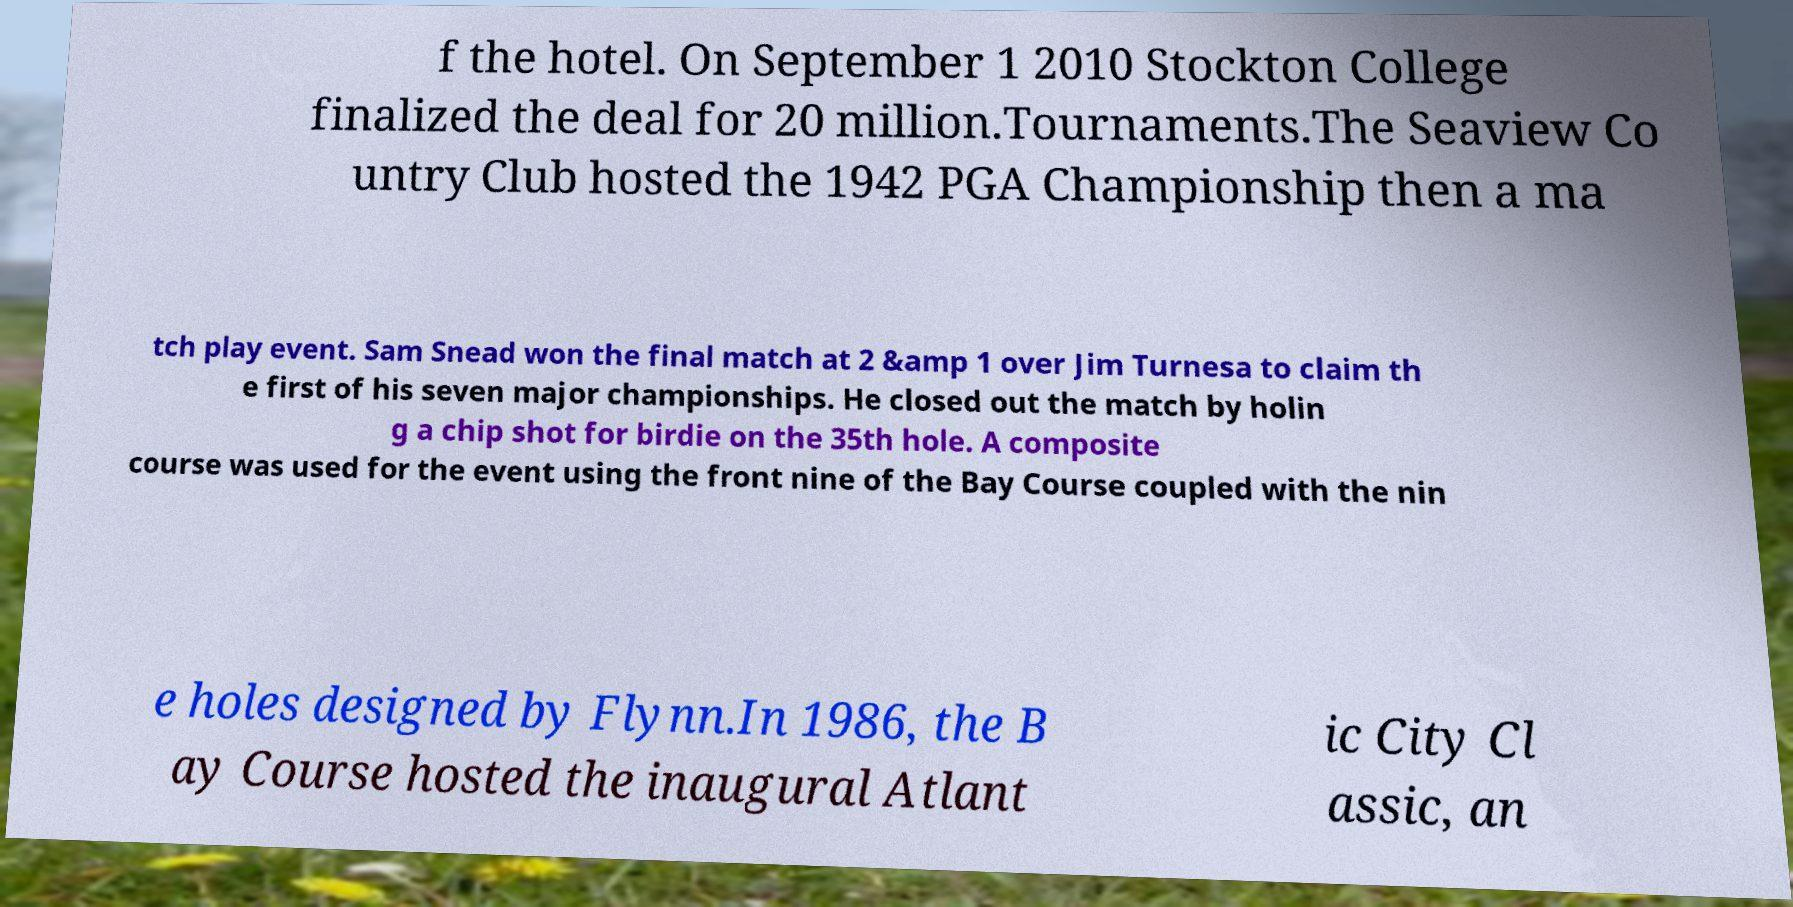Could you extract and type out the text from this image? f the hotel. On September 1 2010 Stockton College finalized the deal for 20 million.Tournaments.The Seaview Co untry Club hosted the 1942 PGA Championship then a ma tch play event. Sam Snead won the final match at 2 &amp 1 over Jim Turnesa to claim th e first of his seven major championships. He closed out the match by holin g a chip shot for birdie on the 35th hole. A composite course was used for the event using the front nine of the Bay Course coupled with the nin e holes designed by Flynn.In 1986, the B ay Course hosted the inaugural Atlant ic City Cl assic, an 